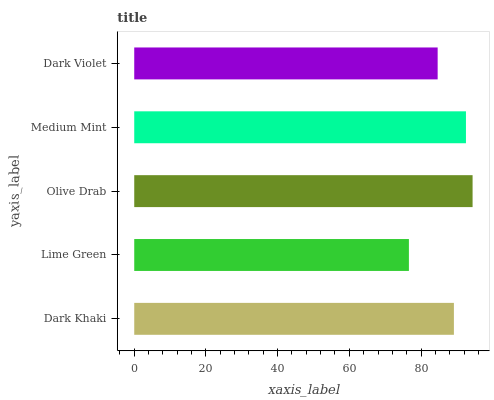Is Lime Green the minimum?
Answer yes or no. Yes. Is Olive Drab the maximum?
Answer yes or no. Yes. Is Olive Drab the minimum?
Answer yes or no. No. Is Lime Green the maximum?
Answer yes or no. No. Is Olive Drab greater than Lime Green?
Answer yes or no. Yes. Is Lime Green less than Olive Drab?
Answer yes or no. Yes. Is Lime Green greater than Olive Drab?
Answer yes or no. No. Is Olive Drab less than Lime Green?
Answer yes or no. No. Is Dark Khaki the high median?
Answer yes or no. Yes. Is Dark Khaki the low median?
Answer yes or no. Yes. Is Dark Violet the high median?
Answer yes or no. No. Is Lime Green the low median?
Answer yes or no. No. 